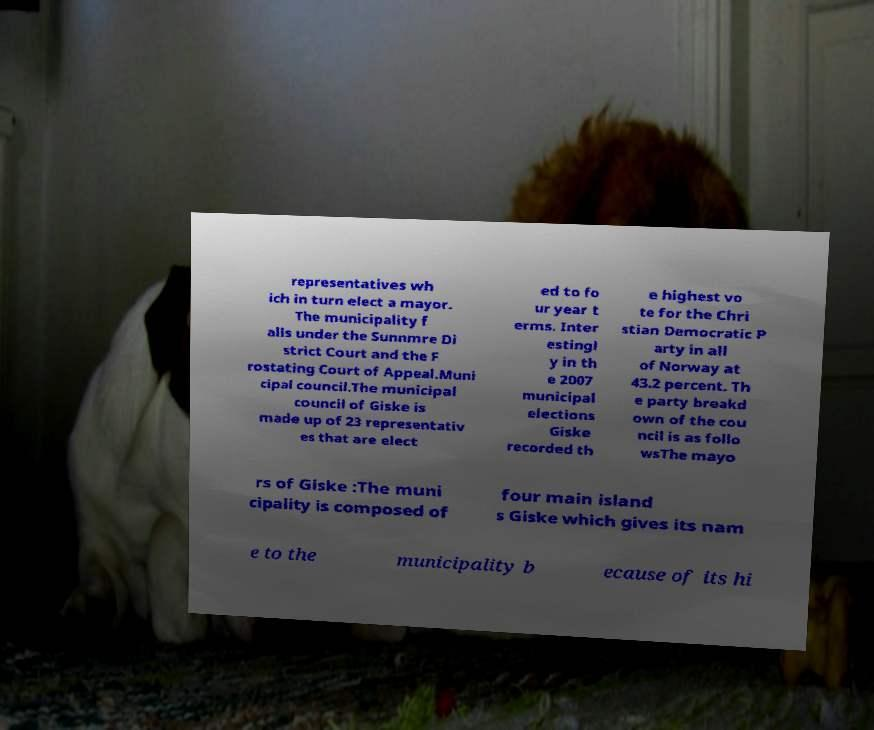Can you accurately transcribe the text from the provided image for me? representatives wh ich in turn elect a mayor. The municipality f alls under the Sunnmre Di strict Court and the F rostating Court of Appeal.Muni cipal council.The municipal council of Giske is made up of 23 representativ es that are elect ed to fo ur year t erms. Inter estingl y in th e 2007 municipal elections Giske recorded th e highest vo te for the Chri stian Democratic P arty in all of Norway at 43.2 percent. Th e party breakd own of the cou ncil is as follo wsThe mayo rs of Giske :The muni cipality is composed of four main island s Giske which gives its nam e to the municipality b ecause of its hi 